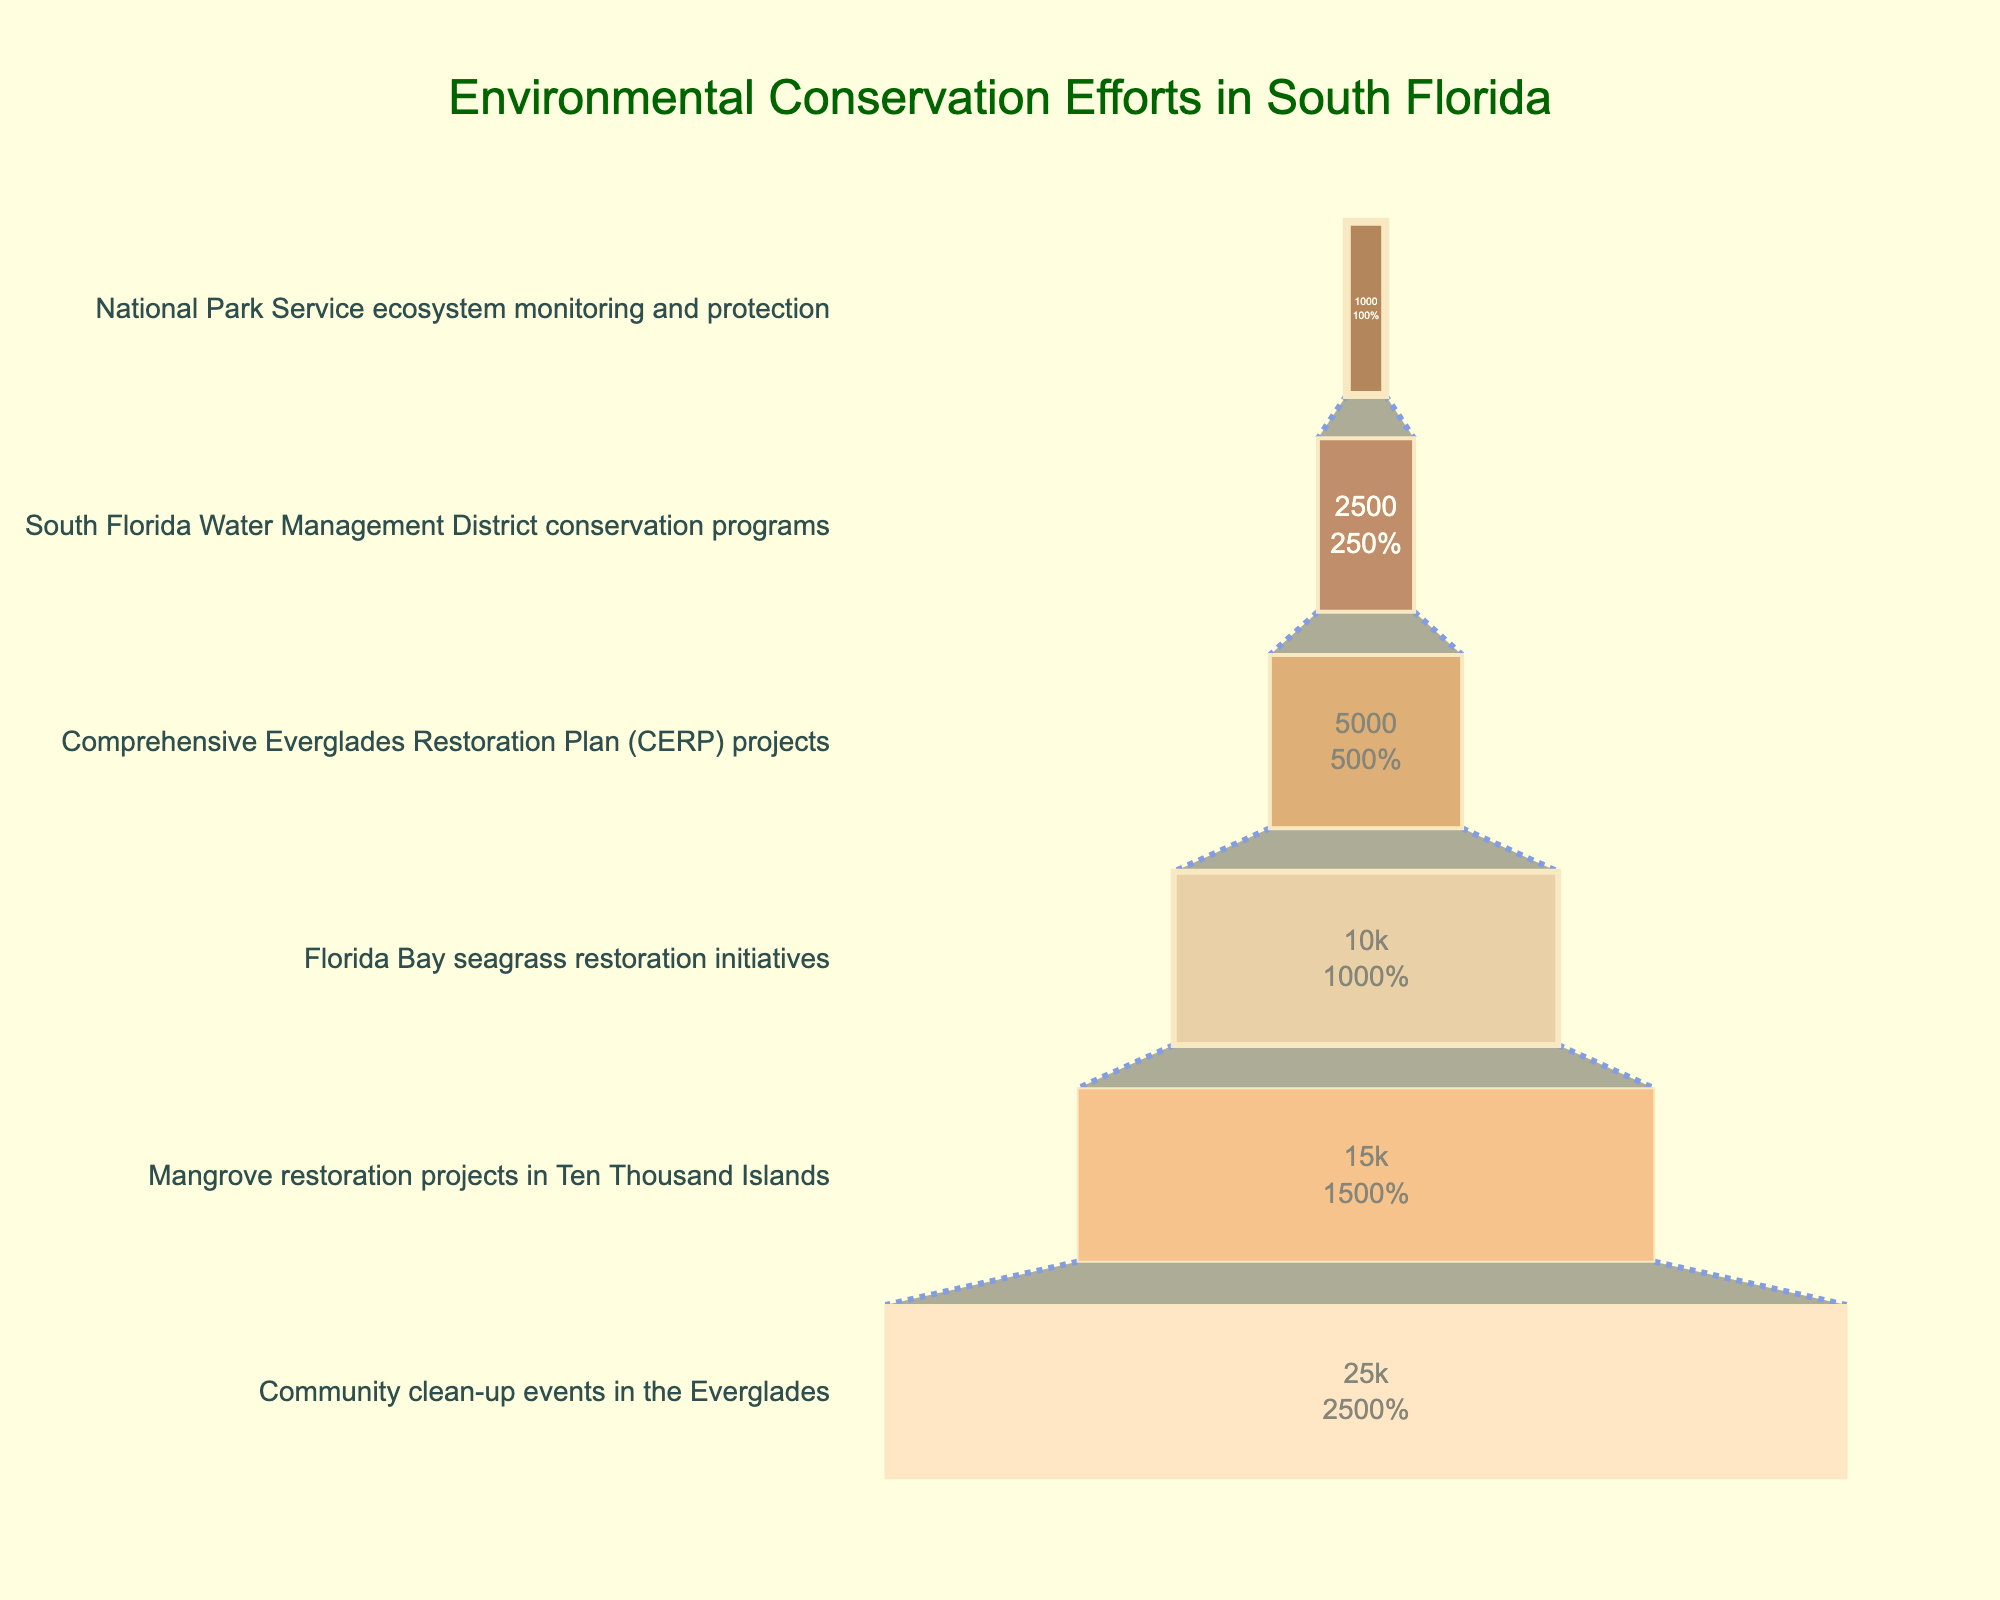What's the total number of participants in all stages? There are 6 stages and their participant numbers are [25000, 15000, 10000, 5000, 2500, 1000]. Summing these values: 25000 + 15000 + 10000 + 5000 + 2500 + 1000 = 58500
Answer: 58500 Which stage has the highest number of participants? The first stage at the top of the funnel chart represents "Community clean-up events in the Everglades" and has the highest value of 25000.
Answer: Community clean-up events in the Everglades What percentage of participants are involved in the "Mangrove restoration projects in Ten Thousand Islands" compared to the initial participant numbers? The initial participant number is 25000. The number of participants in the "Mangrove restoration projects in Ten Thousand Islands" is 15000. Percentage = (15000 / 25000) * 100 = 60%
Answer: 60% What is the difference in participant numbers between the "Florida Bay seagrass restoration initiatives" and "National Park Service ecosystem monitoring and protection"? The number of participants in "Florida Bay seagrass restoration initiatives" is 10000, and in "National Park Service ecosystem monitoring and protection" is 1000. Difference = 10000 - 1000 = 9000
Answer: 9000 Which stages have fewer than 5000 participants? The participants are [2500, 1000] for the stages "South Florida Water Management District conservation programs" and "National Park Service ecosystem monitoring and protection".
Answer: South Florida Water Management District conservation programs, National Park Service ecosystem monitoring and protection How many participants are involved in the "Comprehensive Everglades Restoration Plan (CERP) projects" as a percentage of the total number of participants? The total number of participants in all stages is 58500. The number of participants in "Comprehensive Everglades Restoration Plan (CERP) projects" is 5000. Percentage = (5000 / 58500) * 100 ≈ 8.55%
Answer: 8.55% What's the average number of participants per stage? There are 6 stages and the total number of participants is 58500. Average = 58500 / 6 ≈ 9750
Answer: 9750 What is the ratio of participants between "Community clean-up events in the Everglades" and "South Florida Water Management District conservation programs"? The number of participants in "Community clean-up events in the Everglades" is 25000, and in "South Florida Water Management District conservation programs" is 2500. Ratio = 25000 / 2500 = 10
Answer: 10 